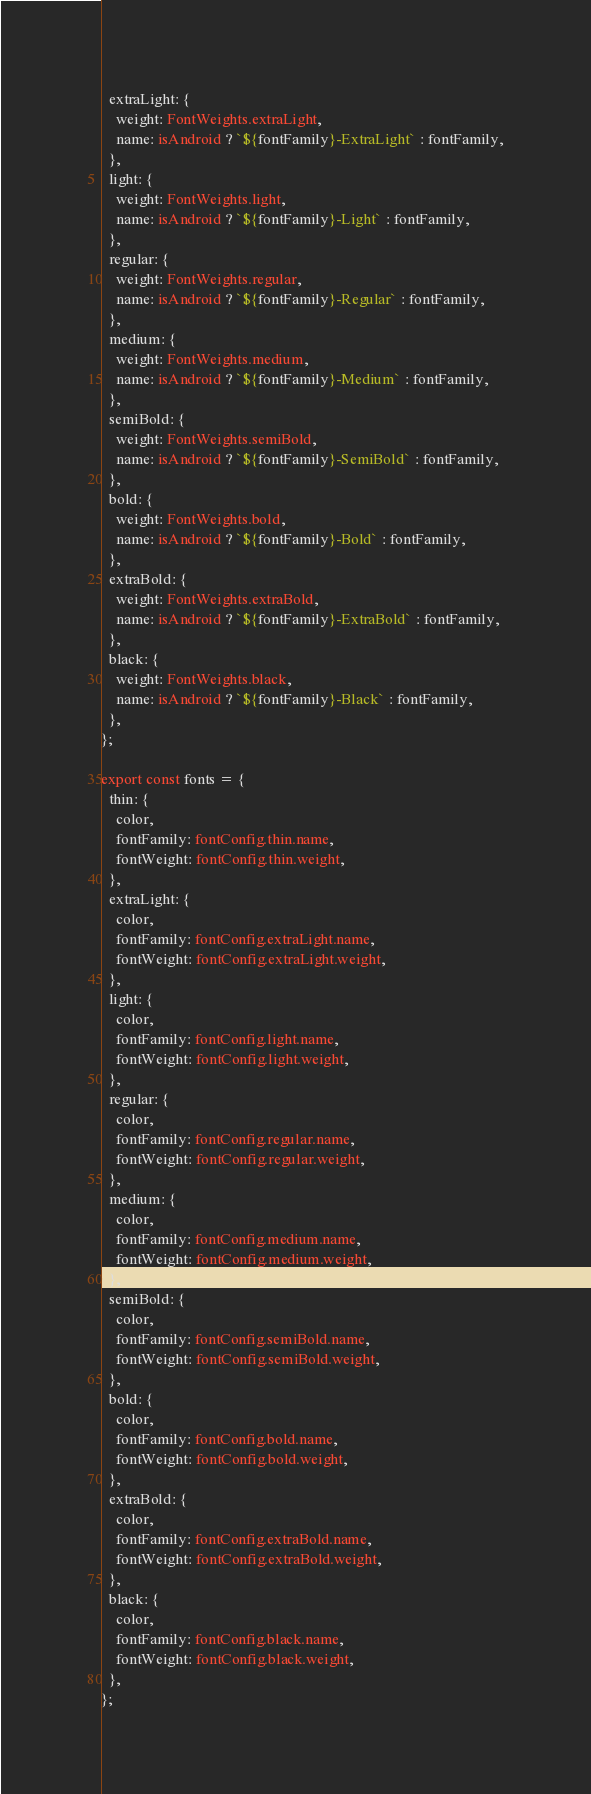<code> <loc_0><loc_0><loc_500><loc_500><_TypeScript_>  extraLight: {
    weight: FontWeights.extraLight,
    name: isAndroid ? `${fontFamily}-ExtraLight` : fontFamily,
  },
  light: {
    weight: FontWeights.light,
    name: isAndroid ? `${fontFamily}-Light` : fontFamily,
  },
  regular: {
    weight: FontWeights.regular,
    name: isAndroid ? `${fontFamily}-Regular` : fontFamily,
  },
  medium: {
    weight: FontWeights.medium,
    name: isAndroid ? `${fontFamily}-Medium` : fontFamily,
  },
  semiBold: {
    weight: FontWeights.semiBold,
    name: isAndroid ? `${fontFamily}-SemiBold` : fontFamily,
  },
  bold: {
    weight: FontWeights.bold,
    name: isAndroid ? `${fontFamily}-Bold` : fontFamily,
  },
  extraBold: {
    weight: FontWeights.extraBold,
    name: isAndroid ? `${fontFamily}-ExtraBold` : fontFamily,
  },
  black: {
    weight: FontWeights.black,
    name: isAndroid ? `${fontFamily}-Black` : fontFamily,
  },
};

export const fonts = {
  thin: {
    color,
    fontFamily: fontConfig.thin.name,
    fontWeight: fontConfig.thin.weight,
  },
  extraLight: {
    color,
    fontFamily: fontConfig.extraLight.name,
    fontWeight: fontConfig.extraLight.weight,
  },
  light: {
    color,
    fontFamily: fontConfig.light.name,
    fontWeight: fontConfig.light.weight,
  },
  regular: {
    color,
    fontFamily: fontConfig.regular.name,
    fontWeight: fontConfig.regular.weight,
  },
  medium: {
    color,
    fontFamily: fontConfig.medium.name,
    fontWeight: fontConfig.medium.weight,
  },
  semiBold: {
    color,
    fontFamily: fontConfig.semiBold.name,
    fontWeight: fontConfig.semiBold.weight,
  },
  bold: {
    color,
    fontFamily: fontConfig.bold.name,
    fontWeight: fontConfig.bold.weight,
  },
  extraBold: {
    color,
    fontFamily: fontConfig.extraBold.name,
    fontWeight: fontConfig.extraBold.weight,
  },
  black: {
    color,
    fontFamily: fontConfig.black.name,
    fontWeight: fontConfig.black.weight,
  },
};
</code> 